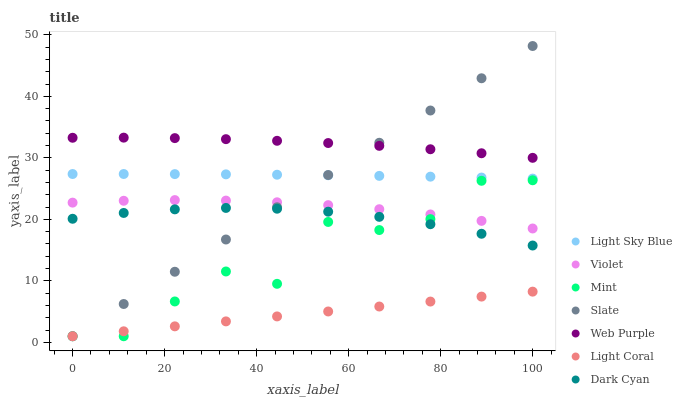Does Light Coral have the minimum area under the curve?
Answer yes or no. Yes. Does Web Purple have the maximum area under the curve?
Answer yes or no. Yes. Does Web Purple have the minimum area under the curve?
Answer yes or no. No. Does Light Coral have the maximum area under the curve?
Answer yes or no. No. Is Light Coral the smoothest?
Answer yes or no. Yes. Is Mint the roughest?
Answer yes or no. Yes. Is Web Purple the smoothest?
Answer yes or no. No. Is Web Purple the roughest?
Answer yes or no. No. Does Slate have the lowest value?
Answer yes or no. Yes. Does Web Purple have the lowest value?
Answer yes or no. No. Does Slate have the highest value?
Answer yes or no. Yes. Does Web Purple have the highest value?
Answer yes or no. No. Is Dark Cyan less than Violet?
Answer yes or no. Yes. Is Web Purple greater than Violet?
Answer yes or no. Yes. Does Mint intersect Violet?
Answer yes or no. Yes. Is Mint less than Violet?
Answer yes or no. No. Is Mint greater than Violet?
Answer yes or no. No. Does Dark Cyan intersect Violet?
Answer yes or no. No. 